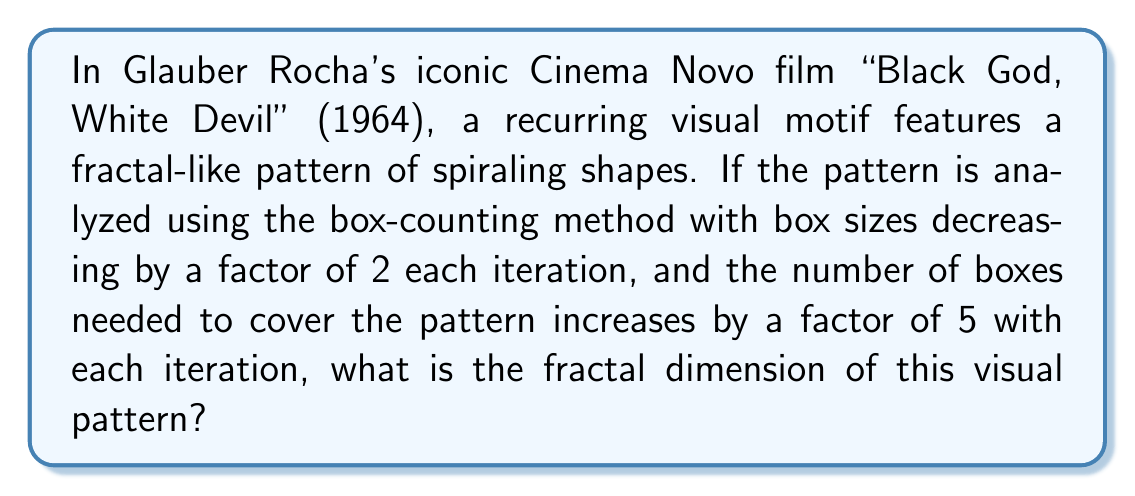Solve this math problem. To determine the fractal dimension using the box-counting method, we need to use the following steps:

1. Recall the formula for fractal dimension (D) using the box-counting method:

   $$D = \frac{\log(N)}{\log(1/r)}$$

   where N is the number of boxes needed to cover the pattern, and r is the scaling factor.

2. In this case, the box sizes are decreasing by a factor of 2 each iteration, so r = 1/2.

3. The number of boxes increases by a factor of 5 each iteration, so N = 5.

4. Substituting these values into the formula:

   $$D = \frac{\log(5)}{\log(2)}$$

5. Evaluate the logarithms:

   $$D = \frac{\log(5)}{\log(2)} \approx \frac{0.6989}{0.3010} \approx 2.3219$$

This fractal dimension indicates that the visual pattern in Rocha's film has a complexity between that of a 2D plane and a 3D object, which is characteristic of many fractal patterns in nature and art.
Answer: $\frac{\log(5)}{\log(2)} \approx 2.3219$ 